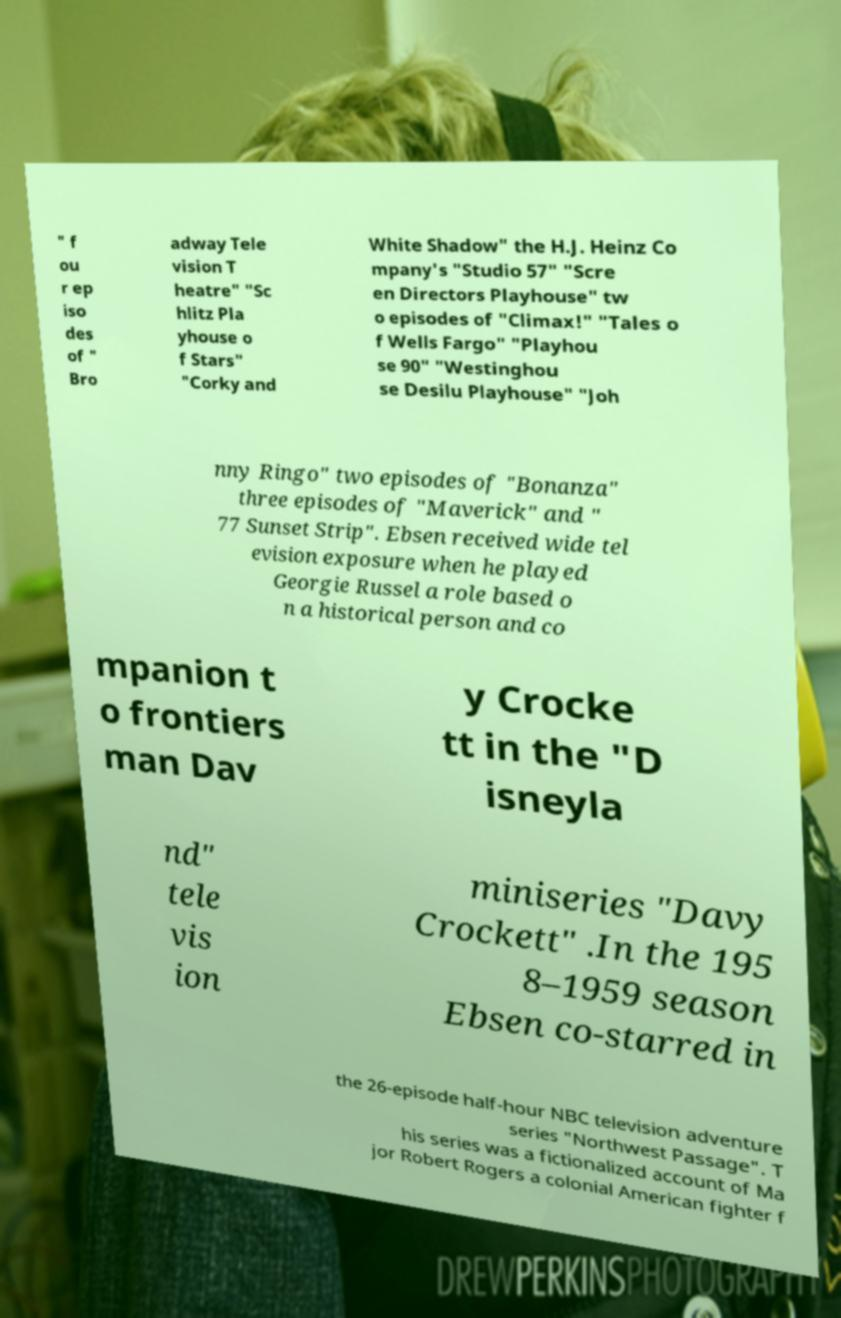Can you read and provide the text displayed in the image?This photo seems to have some interesting text. Can you extract and type it out for me? " f ou r ep iso des of " Bro adway Tele vision T heatre" "Sc hlitz Pla yhouse o f Stars" "Corky and White Shadow" the H.J. Heinz Co mpany's "Studio 57" "Scre en Directors Playhouse" tw o episodes of "Climax!" "Tales o f Wells Fargo" "Playhou se 90" "Westinghou se Desilu Playhouse" "Joh nny Ringo" two episodes of "Bonanza" three episodes of "Maverick" and " 77 Sunset Strip". Ebsen received wide tel evision exposure when he played Georgie Russel a role based o n a historical person and co mpanion t o frontiers man Dav y Crocke tt in the "D isneyla nd" tele vis ion miniseries "Davy Crockett" .In the 195 8–1959 season Ebsen co-starred in the 26-episode half-hour NBC television adventure series "Northwest Passage". T his series was a fictionalized account of Ma jor Robert Rogers a colonial American fighter f 